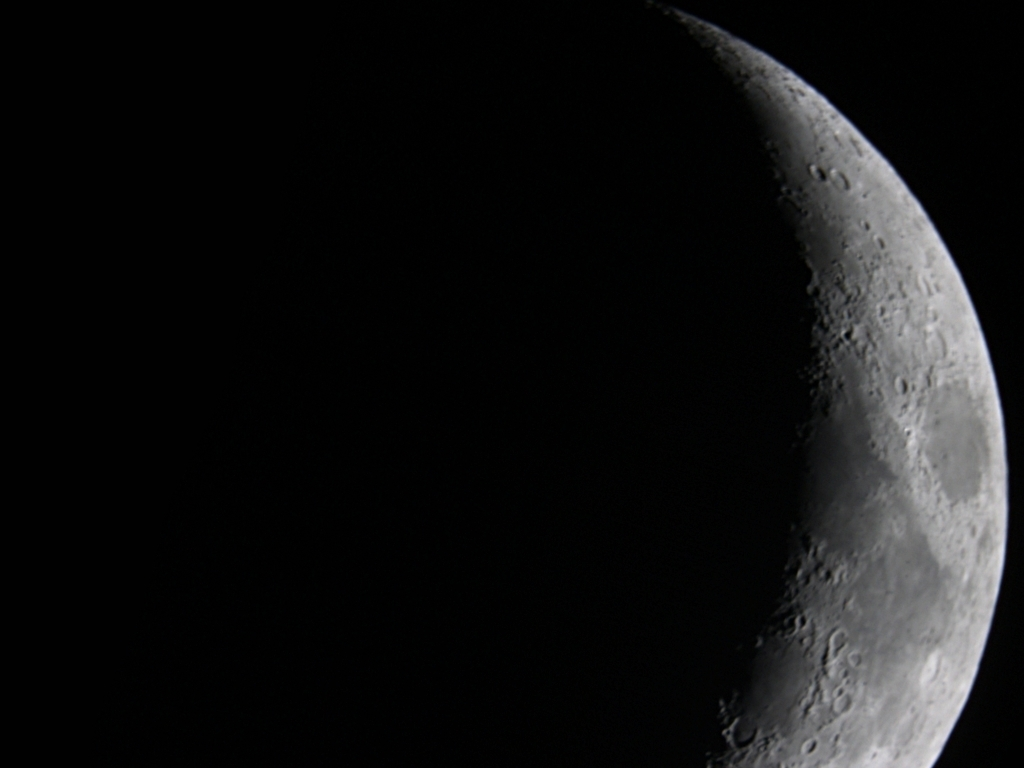What does the darkness and light in this image suggest about the moon's topography? The contrast between the dark and light areas in the image suggests significant topographical variation. The brightly lit regions are higher elevations catching the sunlight, while the darker areas are shadows cast in lower regions or craters. This interplay of light and shadow helps accentuate the rugged terrain and provides a three-dimensional perspective on the moon's surface. 